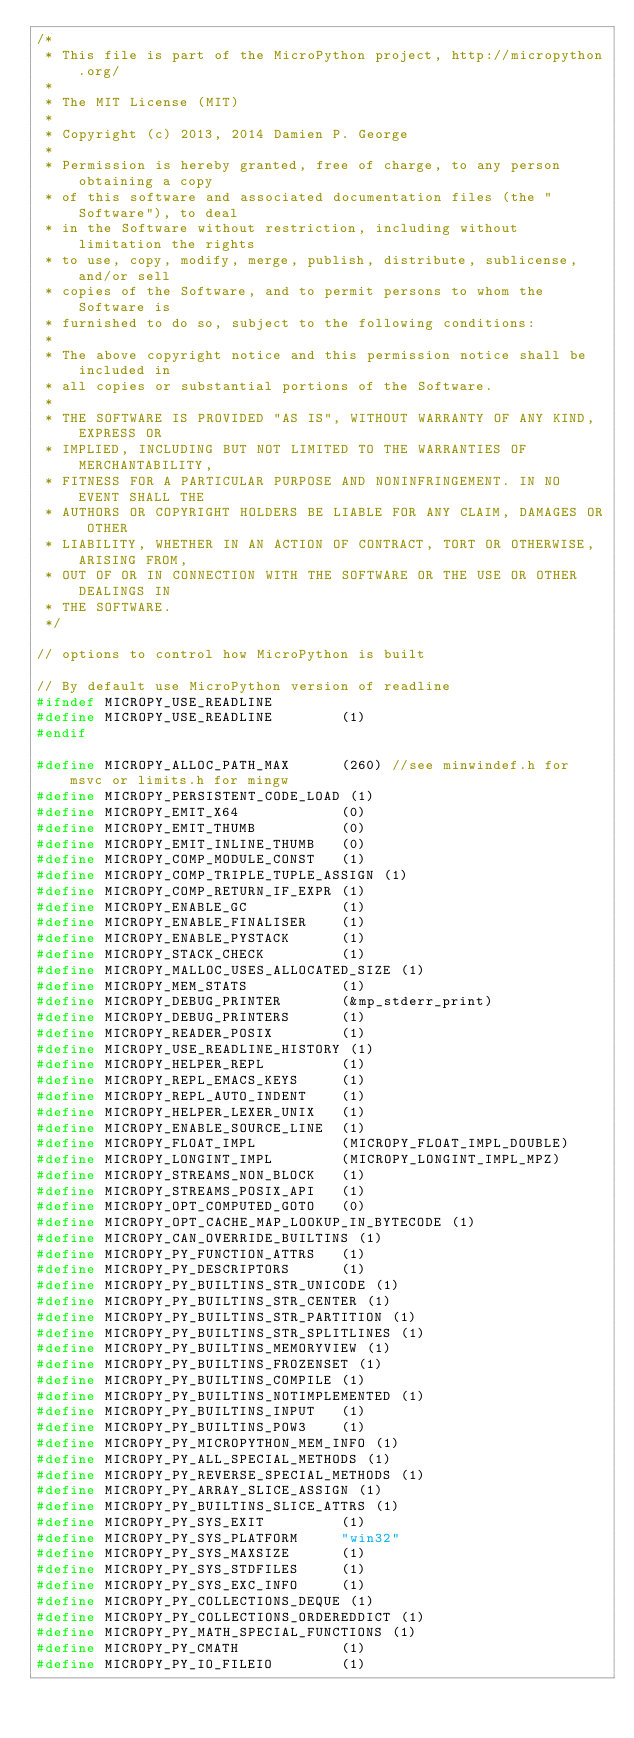Convert code to text. <code><loc_0><loc_0><loc_500><loc_500><_C_>/*
 * This file is part of the MicroPython project, http://micropython.org/
 *
 * The MIT License (MIT)
 *
 * Copyright (c) 2013, 2014 Damien P. George
 *
 * Permission is hereby granted, free of charge, to any person obtaining a copy
 * of this software and associated documentation files (the "Software"), to deal
 * in the Software without restriction, including without limitation the rights
 * to use, copy, modify, merge, publish, distribute, sublicense, and/or sell
 * copies of the Software, and to permit persons to whom the Software is
 * furnished to do so, subject to the following conditions:
 *
 * The above copyright notice and this permission notice shall be included in
 * all copies or substantial portions of the Software.
 *
 * THE SOFTWARE IS PROVIDED "AS IS", WITHOUT WARRANTY OF ANY KIND, EXPRESS OR
 * IMPLIED, INCLUDING BUT NOT LIMITED TO THE WARRANTIES OF MERCHANTABILITY,
 * FITNESS FOR A PARTICULAR PURPOSE AND NONINFRINGEMENT. IN NO EVENT SHALL THE
 * AUTHORS OR COPYRIGHT HOLDERS BE LIABLE FOR ANY CLAIM, DAMAGES OR OTHER
 * LIABILITY, WHETHER IN AN ACTION OF CONTRACT, TORT OR OTHERWISE, ARISING FROM,
 * OUT OF OR IN CONNECTION WITH THE SOFTWARE OR THE USE OR OTHER DEALINGS IN
 * THE SOFTWARE.
 */

// options to control how MicroPython is built

// By default use MicroPython version of readline
#ifndef MICROPY_USE_READLINE
#define MICROPY_USE_READLINE        (1)
#endif

#define MICROPY_ALLOC_PATH_MAX      (260) //see minwindef.h for msvc or limits.h for mingw
#define MICROPY_PERSISTENT_CODE_LOAD (1)
#define MICROPY_EMIT_X64            (0)
#define MICROPY_EMIT_THUMB          (0)
#define MICROPY_EMIT_INLINE_THUMB   (0)
#define MICROPY_COMP_MODULE_CONST   (1)
#define MICROPY_COMP_TRIPLE_TUPLE_ASSIGN (1)
#define MICROPY_COMP_RETURN_IF_EXPR (1)
#define MICROPY_ENABLE_GC           (1)
#define MICROPY_ENABLE_FINALISER    (1)
#define MICROPY_ENABLE_PYSTACK      (1)
#define MICROPY_STACK_CHECK         (1)
#define MICROPY_MALLOC_USES_ALLOCATED_SIZE (1)
#define MICROPY_MEM_STATS           (1)
#define MICROPY_DEBUG_PRINTER       (&mp_stderr_print)
#define MICROPY_DEBUG_PRINTERS      (1)
#define MICROPY_READER_POSIX        (1)
#define MICROPY_USE_READLINE_HISTORY (1)
#define MICROPY_HELPER_REPL         (1)
#define MICROPY_REPL_EMACS_KEYS     (1)
#define MICROPY_REPL_AUTO_INDENT    (1)
#define MICROPY_HELPER_LEXER_UNIX   (1)
#define MICROPY_ENABLE_SOURCE_LINE  (1)
#define MICROPY_FLOAT_IMPL          (MICROPY_FLOAT_IMPL_DOUBLE)
#define MICROPY_LONGINT_IMPL        (MICROPY_LONGINT_IMPL_MPZ)
#define MICROPY_STREAMS_NON_BLOCK   (1)
#define MICROPY_STREAMS_POSIX_API   (1)
#define MICROPY_OPT_COMPUTED_GOTO   (0)
#define MICROPY_OPT_CACHE_MAP_LOOKUP_IN_BYTECODE (1)
#define MICROPY_CAN_OVERRIDE_BUILTINS (1)
#define MICROPY_PY_FUNCTION_ATTRS   (1)
#define MICROPY_PY_DESCRIPTORS      (1)
#define MICROPY_PY_BUILTINS_STR_UNICODE (1)
#define MICROPY_PY_BUILTINS_STR_CENTER (1)
#define MICROPY_PY_BUILTINS_STR_PARTITION (1)
#define MICROPY_PY_BUILTINS_STR_SPLITLINES (1)
#define MICROPY_PY_BUILTINS_MEMORYVIEW (1)
#define MICROPY_PY_BUILTINS_FROZENSET (1)
#define MICROPY_PY_BUILTINS_COMPILE (1)
#define MICROPY_PY_BUILTINS_NOTIMPLEMENTED (1)
#define MICROPY_PY_BUILTINS_INPUT   (1)
#define MICROPY_PY_BUILTINS_POW3    (1)
#define MICROPY_PY_MICROPYTHON_MEM_INFO (1)
#define MICROPY_PY_ALL_SPECIAL_METHODS (1)
#define MICROPY_PY_REVERSE_SPECIAL_METHODS (1)
#define MICROPY_PY_ARRAY_SLICE_ASSIGN (1)
#define MICROPY_PY_BUILTINS_SLICE_ATTRS (1)
#define MICROPY_PY_SYS_EXIT         (1)
#define MICROPY_PY_SYS_PLATFORM     "win32"
#define MICROPY_PY_SYS_MAXSIZE      (1)
#define MICROPY_PY_SYS_STDFILES     (1)
#define MICROPY_PY_SYS_EXC_INFO     (1)
#define MICROPY_PY_COLLECTIONS_DEQUE (1)
#define MICROPY_PY_COLLECTIONS_ORDEREDDICT (1)
#define MICROPY_PY_MATH_SPECIAL_FUNCTIONS (1)
#define MICROPY_PY_CMATH            (1)
#define MICROPY_PY_IO_FILEIO        (1)</code> 